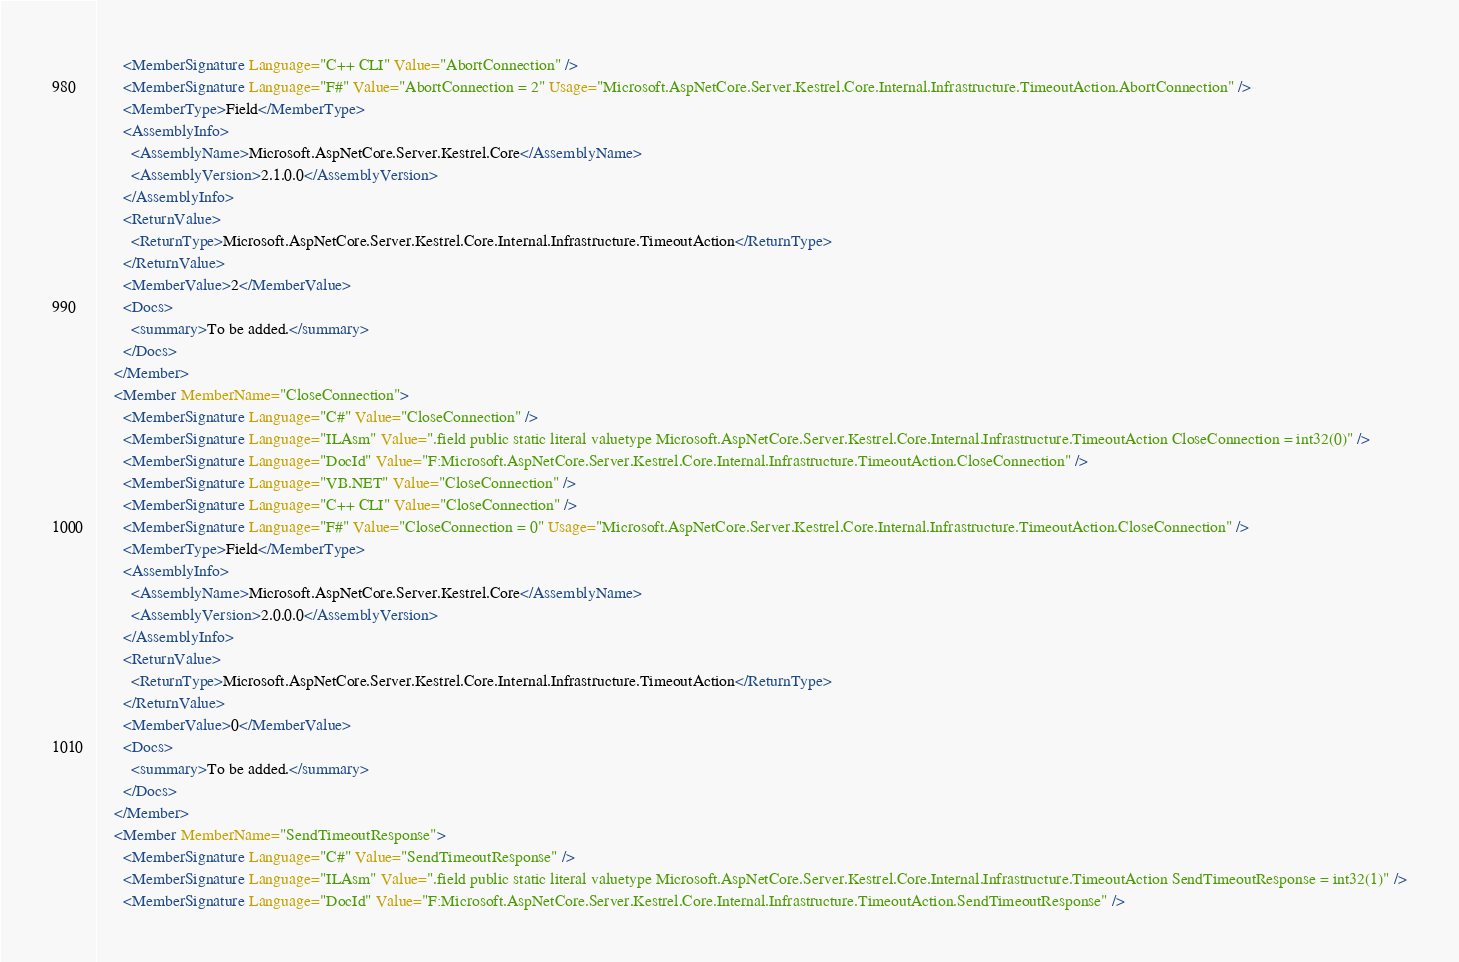<code> <loc_0><loc_0><loc_500><loc_500><_XML_>      <MemberSignature Language="C++ CLI" Value="AbortConnection" />
      <MemberSignature Language="F#" Value="AbortConnection = 2" Usage="Microsoft.AspNetCore.Server.Kestrel.Core.Internal.Infrastructure.TimeoutAction.AbortConnection" />
      <MemberType>Field</MemberType>
      <AssemblyInfo>
        <AssemblyName>Microsoft.AspNetCore.Server.Kestrel.Core</AssemblyName>
        <AssemblyVersion>2.1.0.0</AssemblyVersion>
      </AssemblyInfo>
      <ReturnValue>
        <ReturnType>Microsoft.AspNetCore.Server.Kestrel.Core.Internal.Infrastructure.TimeoutAction</ReturnType>
      </ReturnValue>
      <MemberValue>2</MemberValue>
      <Docs>
        <summary>To be added.</summary>
      </Docs>
    </Member>
    <Member MemberName="CloseConnection">
      <MemberSignature Language="C#" Value="CloseConnection" />
      <MemberSignature Language="ILAsm" Value=".field public static literal valuetype Microsoft.AspNetCore.Server.Kestrel.Core.Internal.Infrastructure.TimeoutAction CloseConnection = int32(0)" />
      <MemberSignature Language="DocId" Value="F:Microsoft.AspNetCore.Server.Kestrel.Core.Internal.Infrastructure.TimeoutAction.CloseConnection" />
      <MemberSignature Language="VB.NET" Value="CloseConnection" />
      <MemberSignature Language="C++ CLI" Value="CloseConnection" />
      <MemberSignature Language="F#" Value="CloseConnection = 0" Usage="Microsoft.AspNetCore.Server.Kestrel.Core.Internal.Infrastructure.TimeoutAction.CloseConnection" />
      <MemberType>Field</MemberType>
      <AssemblyInfo>
        <AssemblyName>Microsoft.AspNetCore.Server.Kestrel.Core</AssemblyName>
        <AssemblyVersion>2.0.0.0</AssemblyVersion>
      </AssemblyInfo>
      <ReturnValue>
        <ReturnType>Microsoft.AspNetCore.Server.Kestrel.Core.Internal.Infrastructure.TimeoutAction</ReturnType>
      </ReturnValue>
      <MemberValue>0</MemberValue>
      <Docs>
        <summary>To be added.</summary>
      </Docs>
    </Member>
    <Member MemberName="SendTimeoutResponse">
      <MemberSignature Language="C#" Value="SendTimeoutResponse" />
      <MemberSignature Language="ILAsm" Value=".field public static literal valuetype Microsoft.AspNetCore.Server.Kestrel.Core.Internal.Infrastructure.TimeoutAction SendTimeoutResponse = int32(1)" />
      <MemberSignature Language="DocId" Value="F:Microsoft.AspNetCore.Server.Kestrel.Core.Internal.Infrastructure.TimeoutAction.SendTimeoutResponse" /></code> 